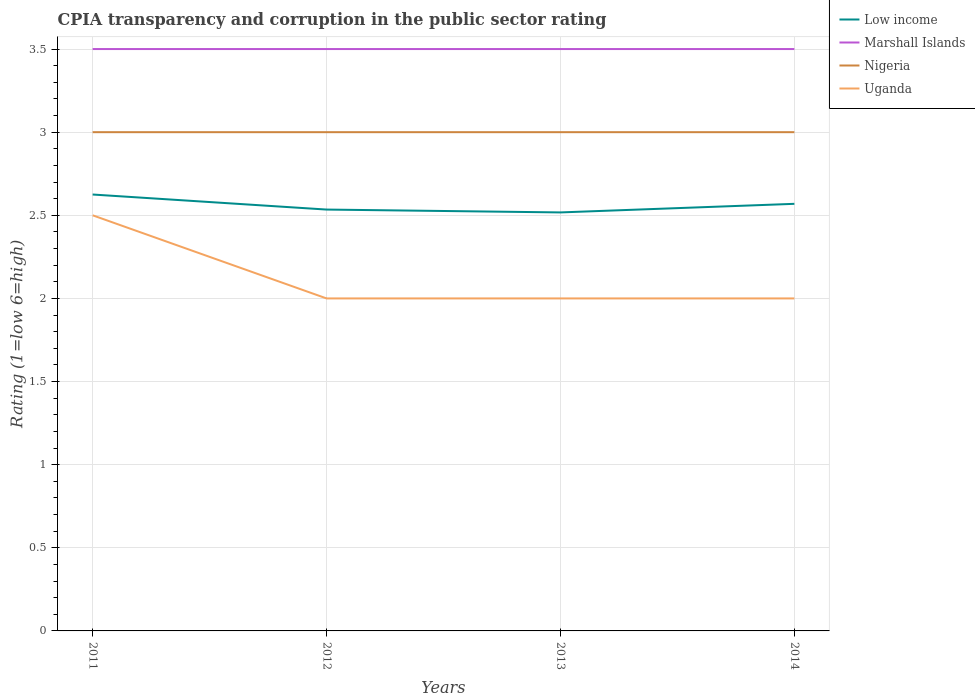Is the number of lines equal to the number of legend labels?
Make the answer very short. Yes. Across all years, what is the maximum CPIA rating in Low income?
Ensure brevity in your answer.  2.52. What is the difference between the highest and the second highest CPIA rating in Low income?
Your answer should be very brief. 0.11. Is the CPIA rating in Marshall Islands strictly greater than the CPIA rating in Nigeria over the years?
Keep it short and to the point. No. How many years are there in the graph?
Provide a short and direct response. 4. Are the values on the major ticks of Y-axis written in scientific E-notation?
Provide a short and direct response. No. Does the graph contain grids?
Provide a short and direct response. Yes. What is the title of the graph?
Ensure brevity in your answer.  CPIA transparency and corruption in the public sector rating. Does "Panama" appear as one of the legend labels in the graph?
Keep it short and to the point. No. What is the label or title of the X-axis?
Make the answer very short. Years. What is the label or title of the Y-axis?
Offer a very short reply. Rating (1=low 6=high). What is the Rating (1=low 6=high) of Low income in 2011?
Keep it short and to the point. 2.62. What is the Rating (1=low 6=high) of Marshall Islands in 2011?
Keep it short and to the point. 3.5. What is the Rating (1=low 6=high) in Low income in 2012?
Your answer should be compact. 2.53. What is the Rating (1=low 6=high) in Marshall Islands in 2012?
Ensure brevity in your answer.  3.5. What is the Rating (1=low 6=high) of Nigeria in 2012?
Keep it short and to the point. 3. What is the Rating (1=low 6=high) in Low income in 2013?
Give a very brief answer. 2.52. What is the Rating (1=low 6=high) of Marshall Islands in 2013?
Your response must be concise. 3.5. What is the Rating (1=low 6=high) of Nigeria in 2013?
Make the answer very short. 3. What is the Rating (1=low 6=high) of Uganda in 2013?
Give a very brief answer. 2. What is the Rating (1=low 6=high) of Low income in 2014?
Your answer should be very brief. 2.57. What is the Rating (1=low 6=high) of Marshall Islands in 2014?
Ensure brevity in your answer.  3.5. What is the Rating (1=low 6=high) in Uganda in 2014?
Your answer should be compact. 2. Across all years, what is the maximum Rating (1=low 6=high) of Low income?
Make the answer very short. 2.62. Across all years, what is the maximum Rating (1=low 6=high) of Nigeria?
Make the answer very short. 3. Across all years, what is the maximum Rating (1=low 6=high) of Uganda?
Your answer should be very brief. 2.5. Across all years, what is the minimum Rating (1=low 6=high) in Low income?
Your response must be concise. 2.52. What is the total Rating (1=low 6=high) of Low income in the graph?
Your answer should be compact. 10.25. What is the difference between the Rating (1=low 6=high) in Low income in 2011 and that in 2012?
Your answer should be very brief. 0.09. What is the difference between the Rating (1=low 6=high) in Marshall Islands in 2011 and that in 2012?
Provide a succinct answer. 0. What is the difference between the Rating (1=low 6=high) of Uganda in 2011 and that in 2012?
Provide a short and direct response. 0.5. What is the difference between the Rating (1=low 6=high) in Low income in 2011 and that in 2013?
Your answer should be very brief. 0.11. What is the difference between the Rating (1=low 6=high) of Nigeria in 2011 and that in 2013?
Offer a terse response. 0. What is the difference between the Rating (1=low 6=high) in Low income in 2011 and that in 2014?
Give a very brief answer. 0.06. What is the difference between the Rating (1=low 6=high) of Marshall Islands in 2011 and that in 2014?
Make the answer very short. 0. What is the difference between the Rating (1=low 6=high) in Low income in 2012 and that in 2013?
Keep it short and to the point. 0.02. What is the difference between the Rating (1=low 6=high) in Uganda in 2012 and that in 2013?
Your answer should be compact. 0. What is the difference between the Rating (1=low 6=high) of Low income in 2012 and that in 2014?
Ensure brevity in your answer.  -0.03. What is the difference between the Rating (1=low 6=high) in Nigeria in 2012 and that in 2014?
Ensure brevity in your answer.  0. What is the difference between the Rating (1=low 6=high) of Uganda in 2012 and that in 2014?
Your answer should be compact. 0. What is the difference between the Rating (1=low 6=high) in Low income in 2013 and that in 2014?
Offer a very short reply. -0.05. What is the difference between the Rating (1=low 6=high) of Marshall Islands in 2013 and that in 2014?
Keep it short and to the point. 0. What is the difference between the Rating (1=low 6=high) of Low income in 2011 and the Rating (1=low 6=high) of Marshall Islands in 2012?
Keep it short and to the point. -0.88. What is the difference between the Rating (1=low 6=high) of Low income in 2011 and the Rating (1=low 6=high) of Nigeria in 2012?
Offer a very short reply. -0.38. What is the difference between the Rating (1=low 6=high) in Marshall Islands in 2011 and the Rating (1=low 6=high) in Nigeria in 2012?
Provide a succinct answer. 0.5. What is the difference between the Rating (1=low 6=high) of Marshall Islands in 2011 and the Rating (1=low 6=high) of Uganda in 2012?
Ensure brevity in your answer.  1.5. What is the difference between the Rating (1=low 6=high) of Low income in 2011 and the Rating (1=low 6=high) of Marshall Islands in 2013?
Provide a short and direct response. -0.88. What is the difference between the Rating (1=low 6=high) in Low income in 2011 and the Rating (1=low 6=high) in Nigeria in 2013?
Ensure brevity in your answer.  -0.38. What is the difference between the Rating (1=low 6=high) of Low income in 2011 and the Rating (1=low 6=high) of Uganda in 2013?
Your response must be concise. 0.62. What is the difference between the Rating (1=low 6=high) of Nigeria in 2011 and the Rating (1=low 6=high) of Uganda in 2013?
Your answer should be compact. 1. What is the difference between the Rating (1=low 6=high) in Low income in 2011 and the Rating (1=low 6=high) in Marshall Islands in 2014?
Keep it short and to the point. -0.88. What is the difference between the Rating (1=low 6=high) in Low income in 2011 and the Rating (1=low 6=high) in Nigeria in 2014?
Give a very brief answer. -0.38. What is the difference between the Rating (1=low 6=high) in Low income in 2011 and the Rating (1=low 6=high) in Uganda in 2014?
Make the answer very short. 0.62. What is the difference between the Rating (1=low 6=high) of Marshall Islands in 2011 and the Rating (1=low 6=high) of Uganda in 2014?
Offer a terse response. 1.5. What is the difference between the Rating (1=low 6=high) in Low income in 2012 and the Rating (1=low 6=high) in Marshall Islands in 2013?
Your answer should be compact. -0.97. What is the difference between the Rating (1=low 6=high) of Low income in 2012 and the Rating (1=low 6=high) of Nigeria in 2013?
Make the answer very short. -0.47. What is the difference between the Rating (1=low 6=high) in Low income in 2012 and the Rating (1=low 6=high) in Uganda in 2013?
Your response must be concise. 0.53. What is the difference between the Rating (1=low 6=high) in Low income in 2012 and the Rating (1=low 6=high) in Marshall Islands in 2014?
Your answer should be compact. -0.97. What is the difference between the Rating (1=low 6=high) in Low income in 2012 and the Rating (1=low 6=high) in Nigeria in 2014?
Provide a succinct answer. -0.47. What is the difference between the Rating (1=low 6=high) of Low income in 2012 and the Rating (1=low 6=high) of Uganda in 2014?
Your answer should be very brief. 0.53. What is the difference between the Rating (1=low 6=high) of Marshall Islands in 2012 and the Rating (1=low 6=high) of Uganda in 2014?
Keep it short and to the point. 1.5. What is the difference between the Rating (1=low 6=high) in Low income in 2013 and the Rating (1=low 6=high) in Marshall Islands in 2014?
Your answer should be compact. -0.98. What is the difference between the Rating (1=low 6=high) in Low income in 2013 and the Rating (1=low 6=high) in Nigeria in 2014?
Your answer should be very brief. -0.48. What is the difference between the Rating (1=low 6=high) of Low income in 2013 and the Rating (1=low 6=high) of Uganda in 2014?
Offer a terse response. 0.52. What is the difference between the Rating (1=low 6=high) in Marshall Islands in 2013 and the Rating (1=low 6=high) in Nigeria in 2014?
Provide a short and direct response. 0.5. What is the difference between the Rating (1=low 6=high) of Nigeria in 2013 and the Rating (1=low 6=high) of Uganda in 2014?
Provide a succinct answer. 1. What is the average Rating (1=low 6=high) of Low income per year?
Provide a short and direct response. 2.56. What is the average Rating (1=low 6=high) of Marshall Islands per year?
Your response must be concise. 3.5. What is the average Rating (1=low 6=high) in Nigeria per year?
Your answer should be compact. 3. What is the average Rating (1=low 6=high) in Uganda per year?
Offer a very short reply. 2.12. In the year 2011, what is the difference between the Rating (1=low 6=high) of Low income and Rating (1=low 6=high) of Marshall Islands?
Provide a succinct answer. -0.88. In the year 2011, what is the difference between the Rating (1=low 6=high) in Low income and Rating (1=low 6=high) in Nigeria?
Your answer should be compact. -0.38. In the year 2011, what is the difference between the Rating (1=low 6=high) of Marshall Islands and Rating (1=low 6=high) of Uganda?
Offer a very short reply. 1. In the year 2011, what is the difference between the Rating (1=low 6=high) of Nigeria and Rating (1=low 6=high) of Uganda?
Provide a short and direct response. 0.5. In the year 2012, what is the difference between the Rating (1=low 6=high) in Low income and Rating (1=low 6=high) in Marshall Islands?
Your answer should be compact. -0.97. In the year 2012, what is the difference between the Rating (1=low 6=high) in Low income and Rating (1=low 6=high) in Nigeria?
Keep it short and to the point. -0.47. In the year 2012, what is the difference between the Rating (1=low 6=high) in Low income and Rating (1=low 6=high) in Uganda?
Provide a short and direct response. 0.53. In the year 2012, what is the difference between the Rating (1=low 6=high) of Marshall Islands and Rating (1=low 6=high) of Uganda?
Ensure brevity in your answer.  1.5. In the year 2012, what is the difference between the Rating (1=low 6=high) of Nigeria and Rating (1=low 6=high) of Uganda?
Your answer should be very brief. 1. In the year 2013, what is the difference between the Rating (1=low 6=high) of Low income and Rating (1=low 6=high) of Marshall Islands?
Ensure brevity in your answer.  -0.98. In the year 2013, what is the difference between the Rating (1=low 6=high) in Low income and Rating (1=low 6=high) in Nigeria?
Provide a succinct answer. -0.48. In the year 2013, what is the difference between the Rating (1=low 6=high) in Low income and Rating (1=low 6=high) in Uganda?
Keep it short and to the point. 0.52. In the year 2013, what is the difference between the Rating (1=low 6=high) of Marshall Islands and Rating (1=low 6=high) of Uganda?
Offer a very short reply. 1.5. In the year 2013, what is the difference between the Rating (1=low 6=high) in Nigeria and Rating (1=low 6=high) in Uganda?
Give a very brief answer. 1. In the year 2014, what is the difference between the Rating (1=low 6=high) in Low income and Rating (1=low 6=high) in Marshall Islands?
Offer a very short reply. -0.93. In the year 2014, what is the difference between the Rating (1=low 6=high) of Low income and Rating (1=low 6=high) of Nigeria?
Your answer should be compact. -0.43. In the year 2014, what is the difference between the Rating (1=low 6=high) of Low income and Rating (1=low 6=high) of Uganda?
Your answer should be compact. 0.57. In the year 2014, what is the difference between the Rating (1=low 6=high) of Marshall Islands and Rating (1=low 6=high) of Nigeria?
Offer a terse response. 0.5. In the year 2014, what is the difference between the Rating (1=low 6=high) in Marshall Islands and Rating (1=low 6=high) in Uganda?
Provide a short and direct response. 1.5. In the year 2014, what is the difference between the Rating (1=low 6=high) in Nigeria and Rating (1=low 6=high) in Uganda?
Give a very brief answer. 1. What is the ratio of the Rating (1=low 6=high) of Low income in 2011 to that in 2012?
Make the answer very short. 1.04. What is the ratio of the Rating (1=low 6=high) of Marshall Islands in 2011 to that in 2012?
Provide a short and direct response. 1. What is the ratio of the Rating (1=low 6=high) of Nigeria in 2011 to that in 2012?
Make the answer very short. 1. What is the ratio of the Rating (1=low 6=high) of Uganda in 2011 to that in 2012?
Provide a succinct answer. 1.25. What is the ratio of the Rating (1=low 6=high) in Low income in 2011 to that in 2013?
Offer a terse response. 1.04. What is the ratio of the Rating (1=low 6=high) in Marshall Islands in 2011 to that in 2013?
Ensure brevity in your answer.  1. What is the ratio of the Rating (1=low 6=high) of Nigeria in 2011 to that in 2013?
Your response must be concise. 1. What is the ratio of the Rating (1=low 6=high) of Low income in 2011 to that in 2014?
Your response must be concise. 1.02. What is the ratio of the Rating (1=low 6=high) of Marshall Islands in 2011 to that in 2014?
Give a very brief answer. 1. What is the ratio of the Rating (1=low 6=high) of Low income in 2012 to that in 2013?
Make the answer very short. 1.01. What is the ratio of the Rating (1=low 6=high) of Low income in 2012 to that in 2014?
Provide a short and direct response. 0.99. What is the ratio of the Rating (1=low 6=high) of Nigeria in 2012 to that in 2014?
Offer a very short reply. 1. What is the ratio of the Rating (1=low 6=high) of Uganda in 2012 to that in 2014?
Make the answer very short. 1. What is the ratio of the Rating (1=low 6=high) in Low income in 2013 to that in 2014?
Provide a succinct answer. 0.98. What is the ratio of the Rating (1=low 6=high) in Marshall Islands in 2013 to that in 2014?
Your answer should be very brief. 1. What is the ratio of the Rating (1=low 6=high) of Nigeria in 2013 to that in 2014?
Your response must be concise. 1. What is the ratio of the Rating (1=low 6=high) of Uganda in 2013 to that in 2014?
Your answer should be compact. 1. What is the difference between the highest and the second highest Rating (1=low 6=high) in Low income?
Provide a short and direct response. 0.06. What is the difference between the highest and the second highest Rating (1=low 6=high) of Marshall Islands?
Provide a succinct answer. 0. What is the difference between the highest and the second highest Rating (1=low 6=high) of Nigeria?
Offer a terse response. 0. What is the difference between the highest and the lowest Rating (1=low 6=high) in Low income?
Ensure brevity in your answer.  0.11. What is the difference between the highest and the lowest Rating (1=low 6=high) of Uganda?
Keep it short and to the point. 0.5. 